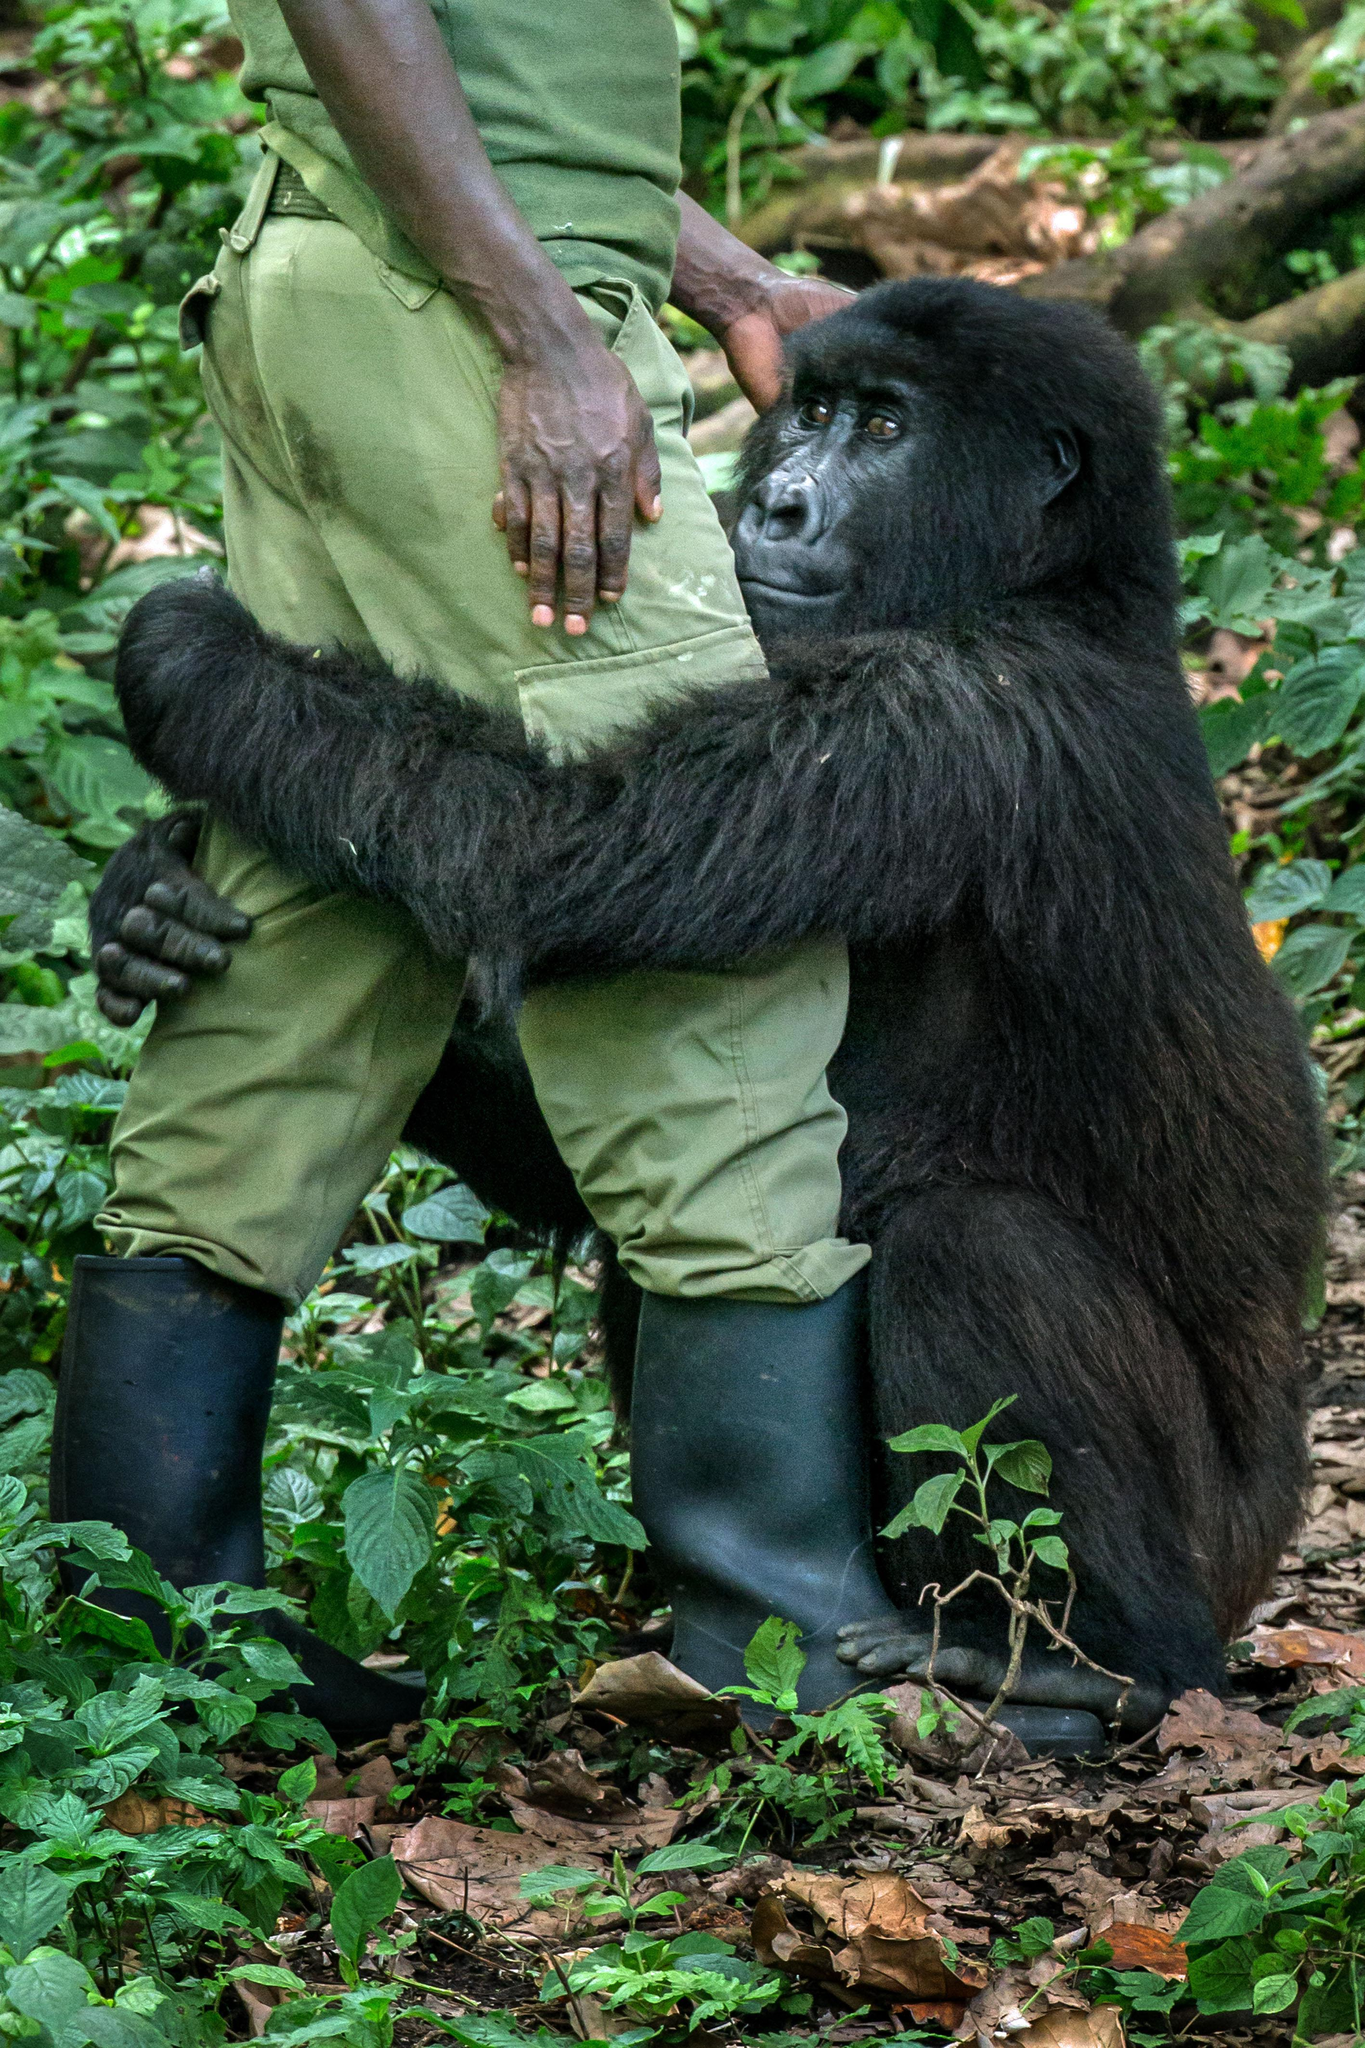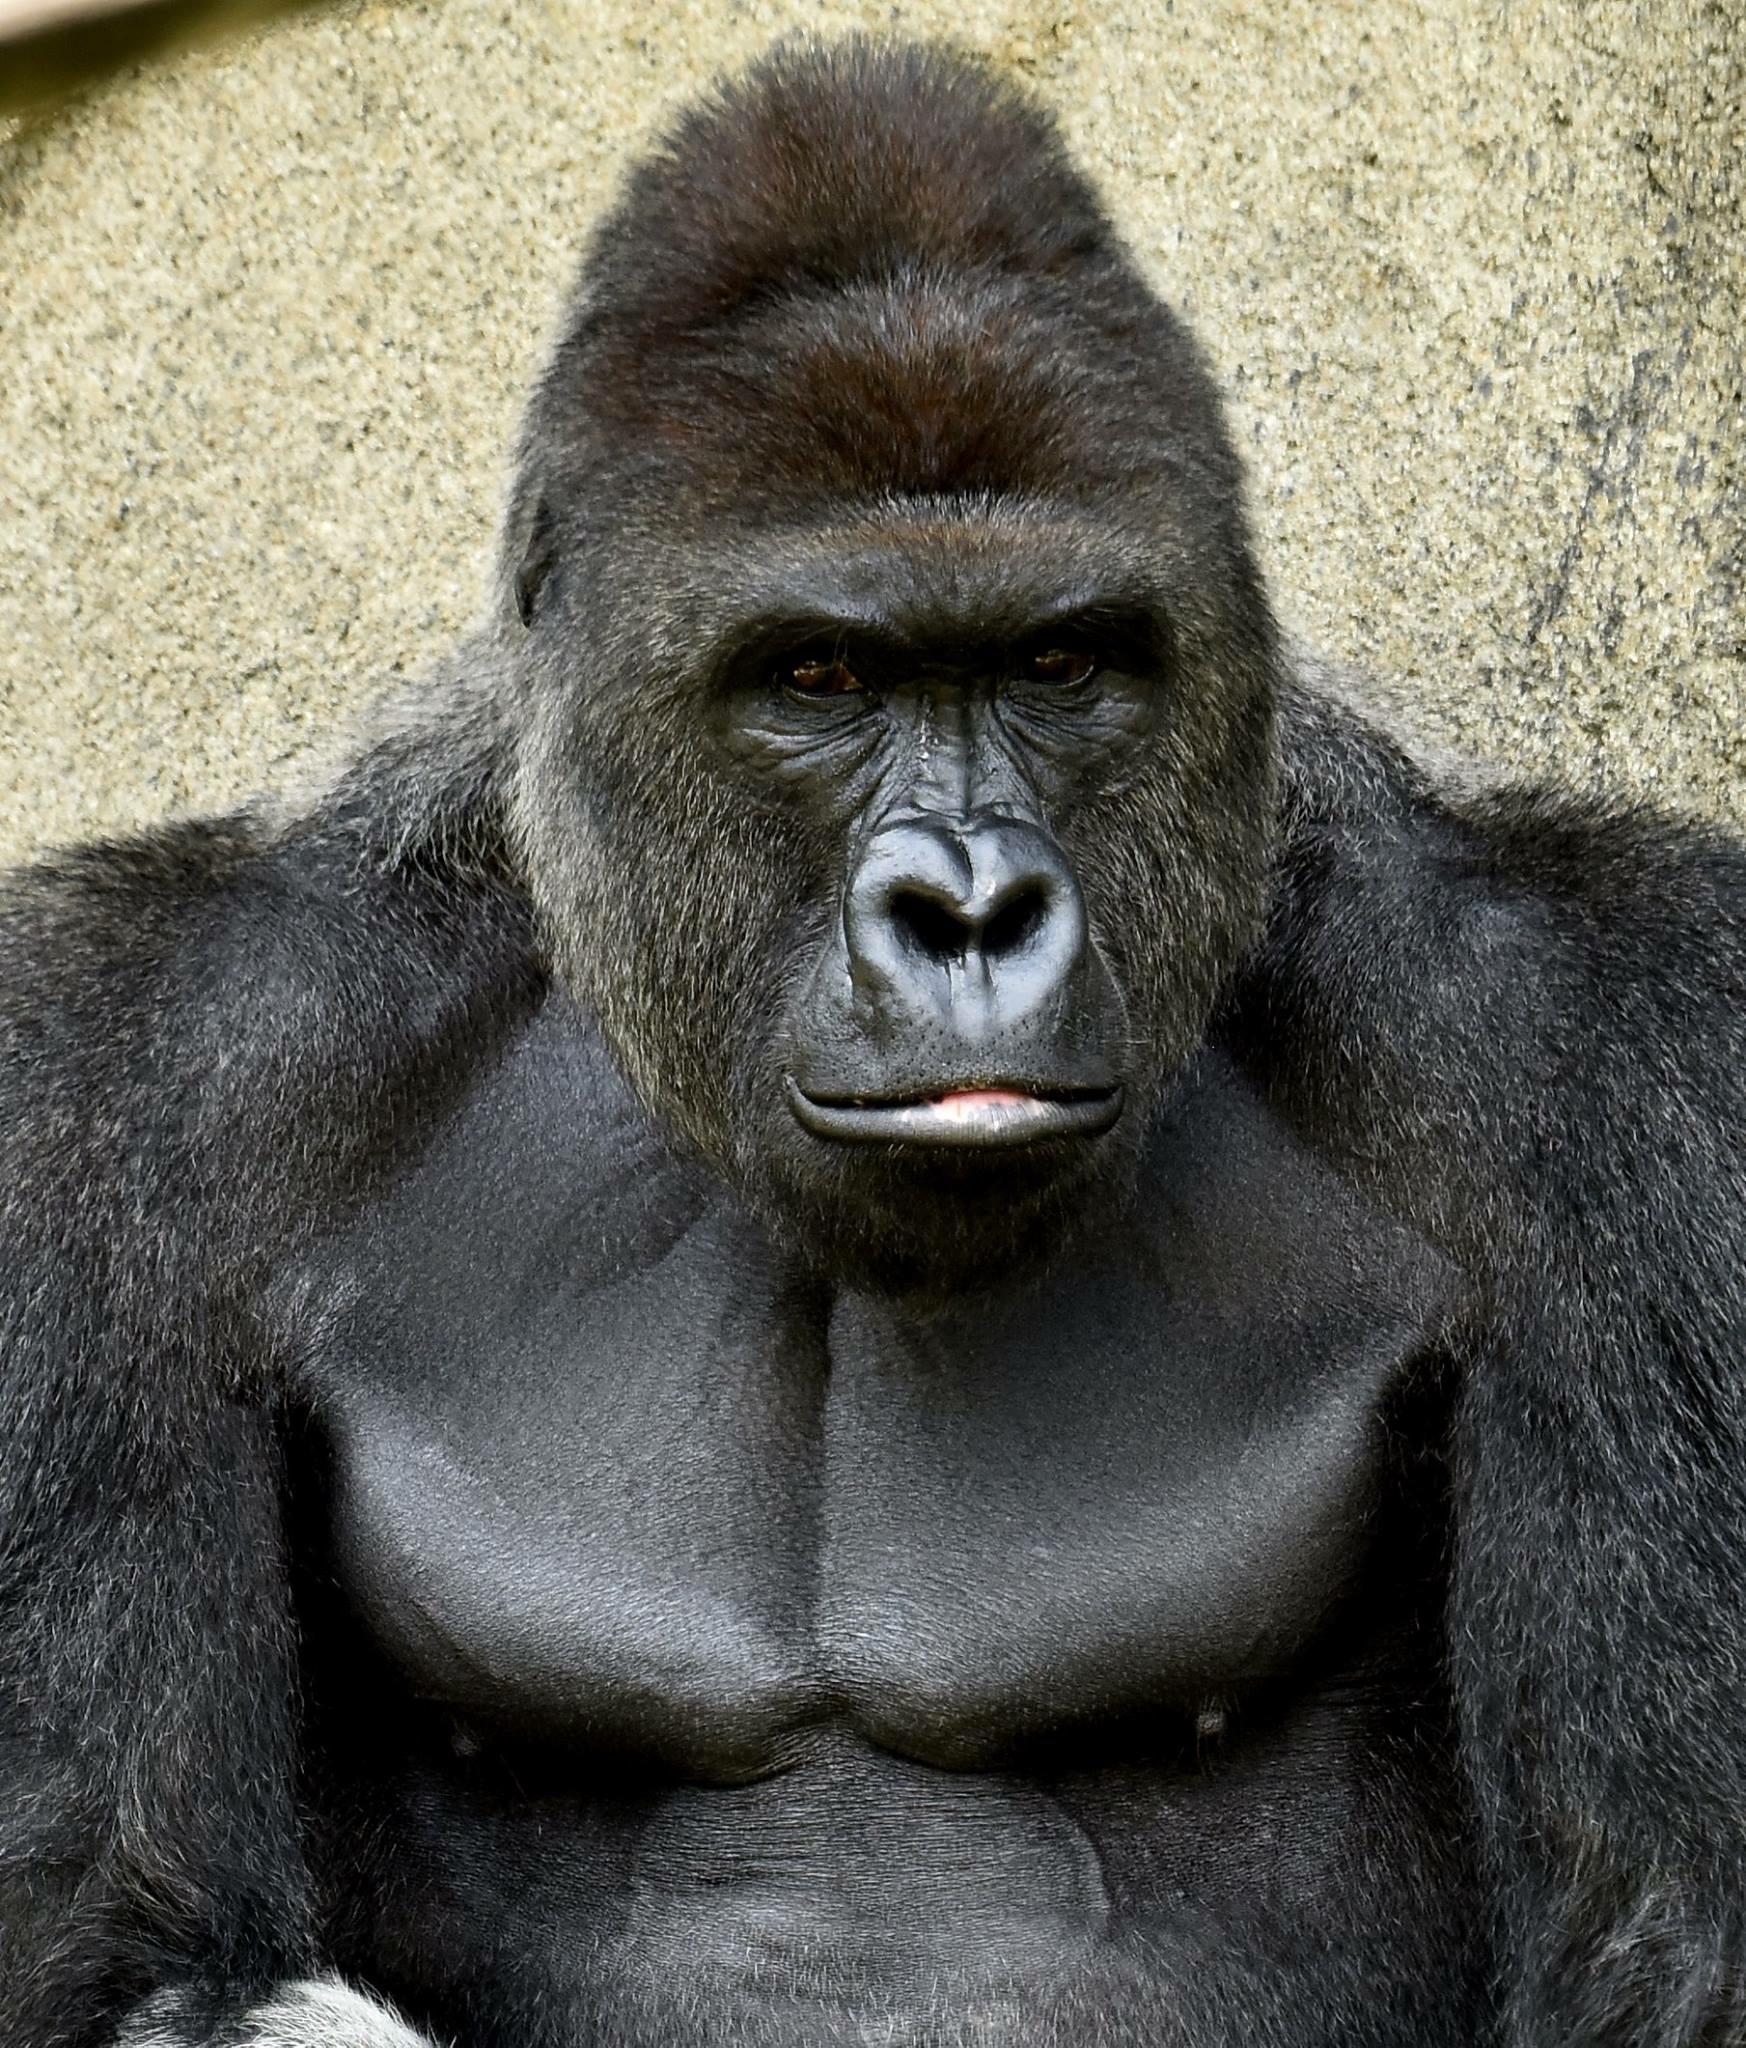The first image is the image on the left, the second image is the image on the right. Given the left and right images, does the statement "One image shows a forward-gazing gorilla clutching at least one infant gorilla to its chest." hold true? Answer yes or no. No. The first image is the image on the left, the second image is the image on the right. Examine the images to the left and right. Is the description "A gorilla is holding a baby gorilla" accurate? Answer yes or no. No. 